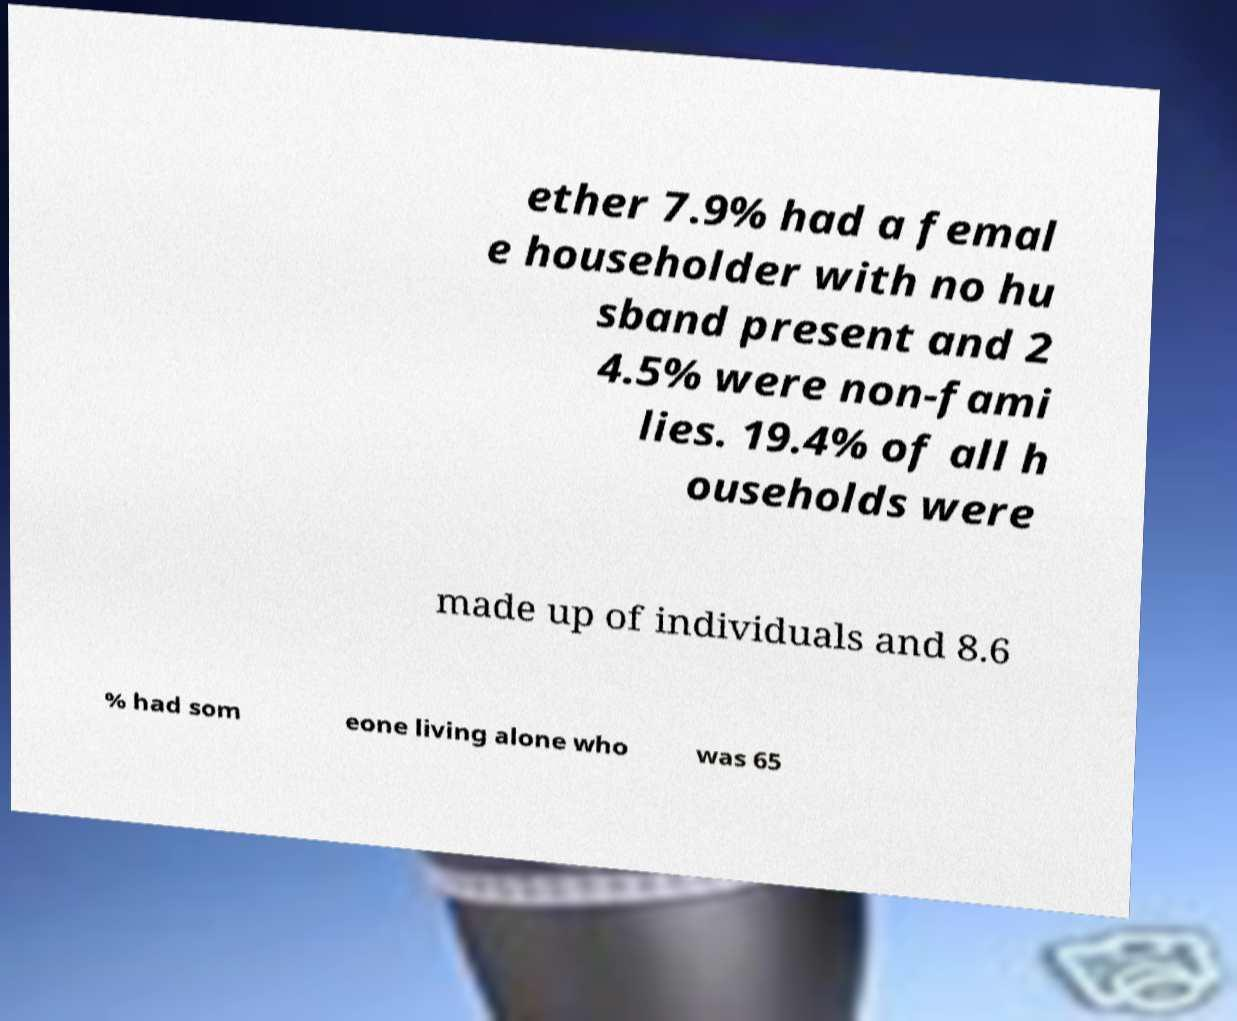For documentation purposes, I need the text within this image transcribed. Could you provide that? ether 7.9% had a femal e householder with no hu sband present and 2 4.5% were non-fami lies. 19.4% of all h ouseholds were made up of individuals and 8.6 % had som eone living alone who was 65 